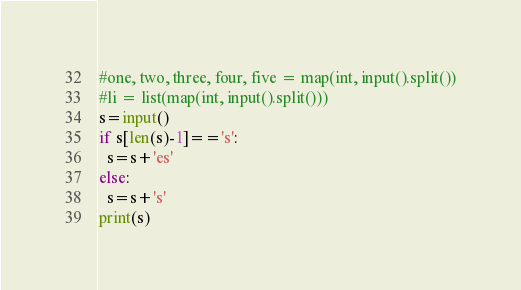<code> <loc_0><loc_0><loc_500><loc_500><_Python_>#one, two, three, four, five = map(int, input().split())
#li = list(map(int, input().split()))
s=input()
if s[len(s)-1]=='s':
  s=s+'es'
else:
  s=s+'s'
print(s)</code> 